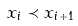<formula> <loc_0><loc_0><loc_500><loc_500>x _ { i } \prec x _ { i + 1 }</formula> 